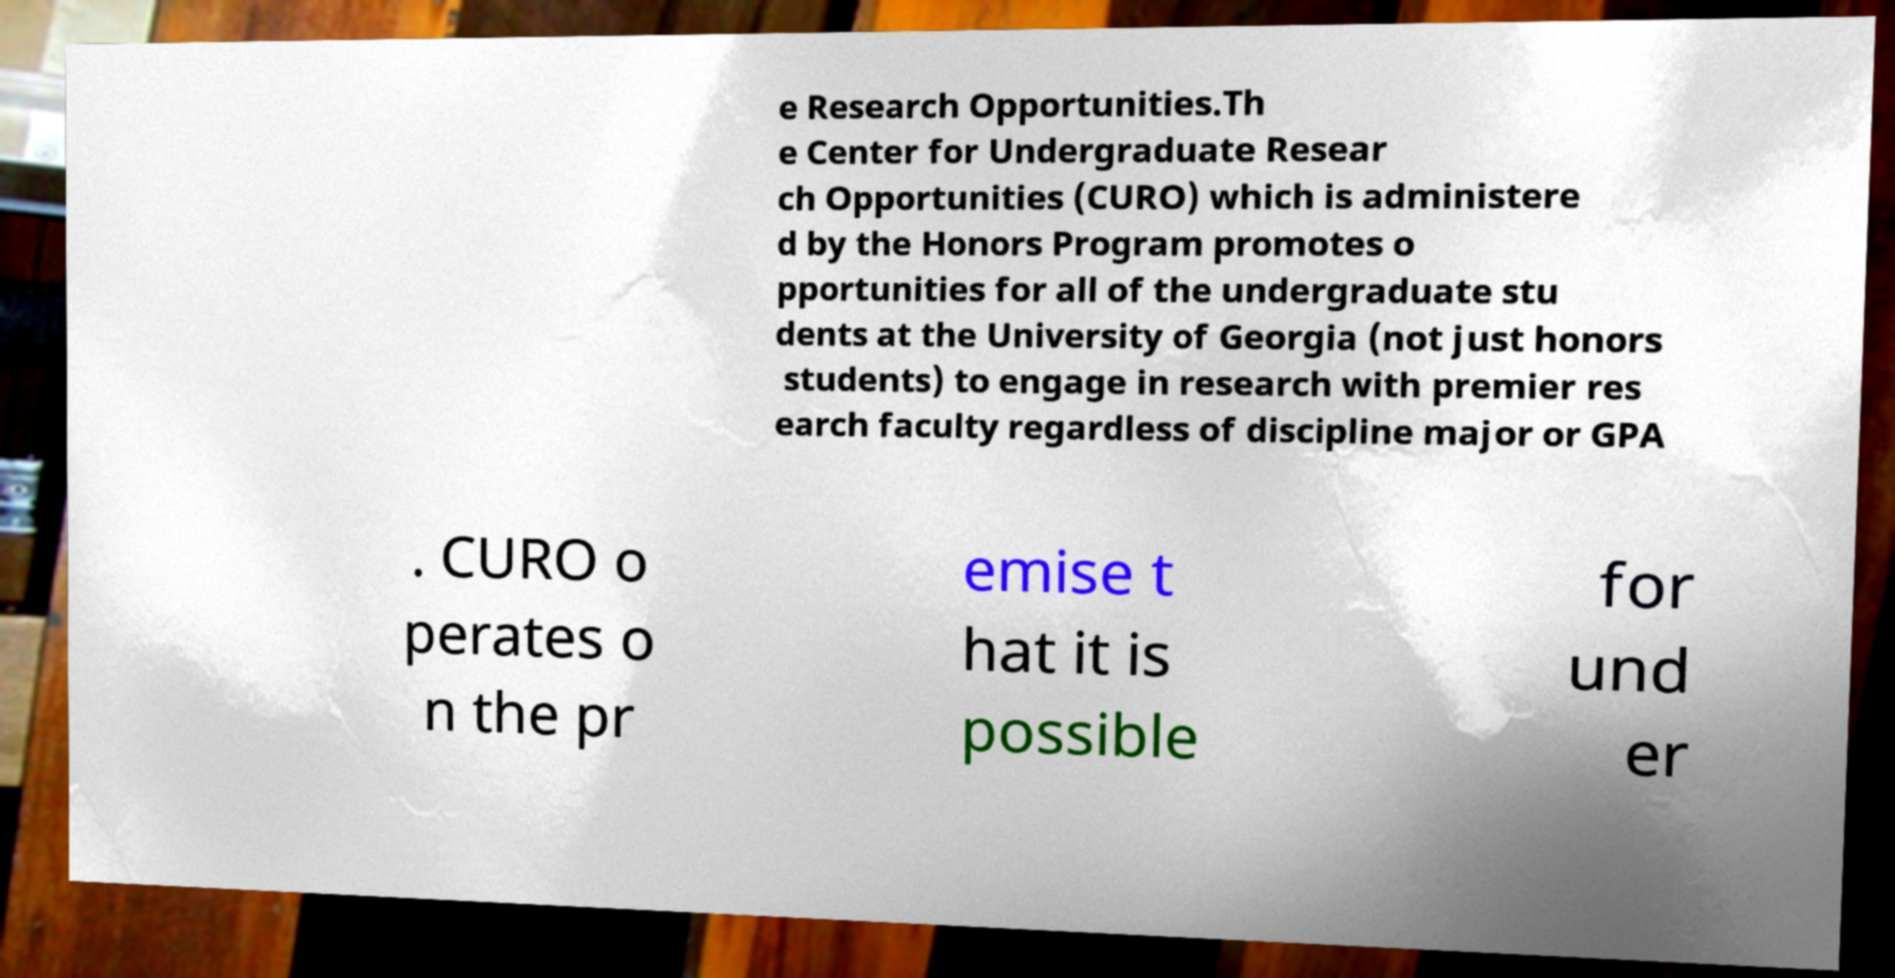Can you accurately transcribe the text from the provided image for me? e Research Opportunities.Th e Center for Undergraduate Resear ch Opportunities (CURO) which is administere d by the Honors Program promotes o pportunities for all of the undergraduate stu dents at the University of Georgia (not just honors students) to engage in research with premier res earch faculty regardless of discipline major or GPA . CURO o perates o n the pr emise t hat it is possible for und er 